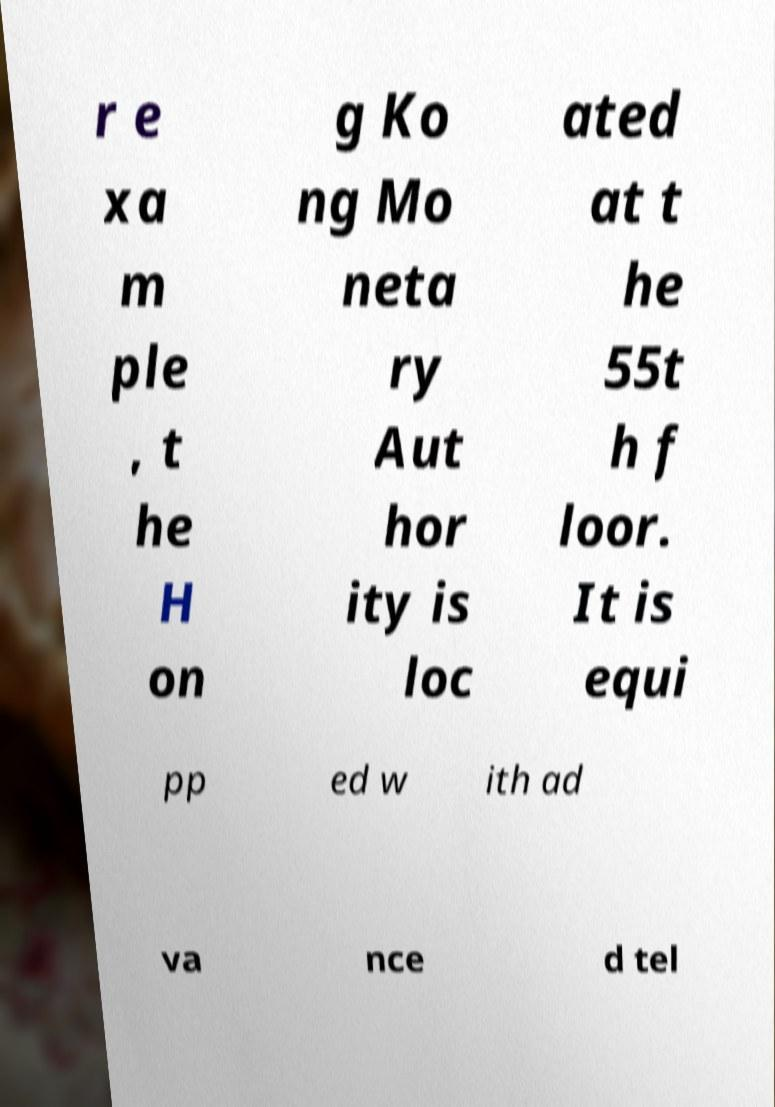Can you accurately transcribe the text from the provided image for me? r e xa m ple , t he H on g Ko ng Mo neta ry Aut hor ity is loc ated at t he 55t h f loor. It is equi pp ed w ith ad va nce d tel 